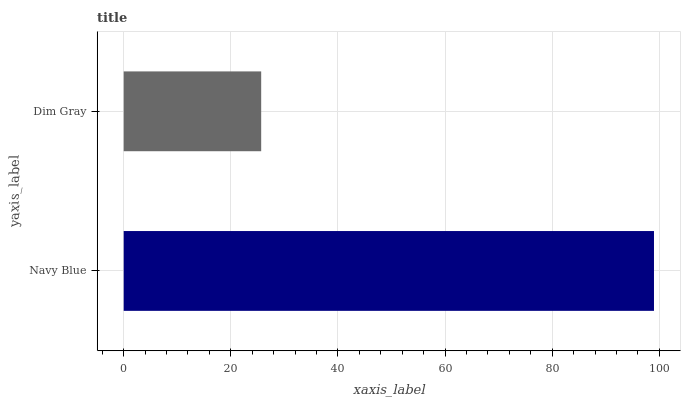Is Dim Gray the minimum?
Answer yes or no. Yes. Is Navy Blue the maximum?
Answer yes or no. Yes. Is Dim Gray the maximum?
Answer yes or no. No. Is Navy Blue greater than Dim Gray?
Answer yes or no. Yes. Is Dim Gray less than Navy Blue?
Answer yes or no. Yes. Is Dim Gray greater than Navy Blue?
Answer yes or no. No. Is Navy Blue less than Dim Gray?
Answer yes or no. No. Is Navy Blue the high median?
Answer yes or no. Yes. Is Dim Gray the low median?
Answer yes or no. Yes. Is Dim Gray the high median?
Answer yes or no. No. Is Navy Blue the low median?
Answer yes or no. No. 